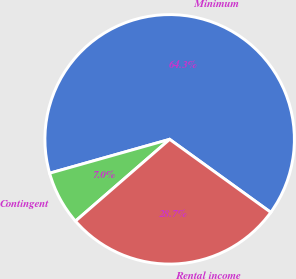Convert chart to OTSL. <chart><loc_0><loc_0><loc_500><loc_500><pie_chart><fcel>Minimum<fcel>Contingent<fcel>Rental income<nl><fcel>64.33%<fcel>7.0%<fcel>28.67%<nl></chart> 